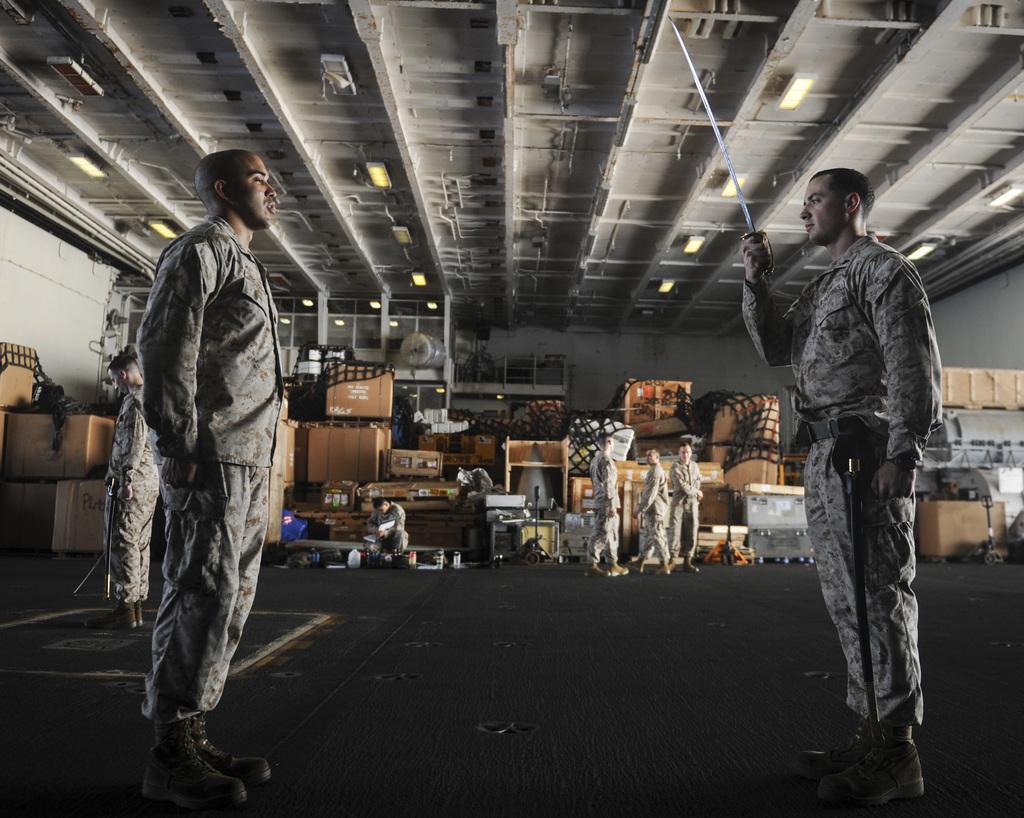Please provide a concise description of this image. In this image I can see few men are wearing uniforms and standing on the floor. The man who is standing on the right side is holding a sword in the hand and looking at the man who is standing in front of him. In the background, I can see some tables, boxes and a wall. This is looking like a shed. 